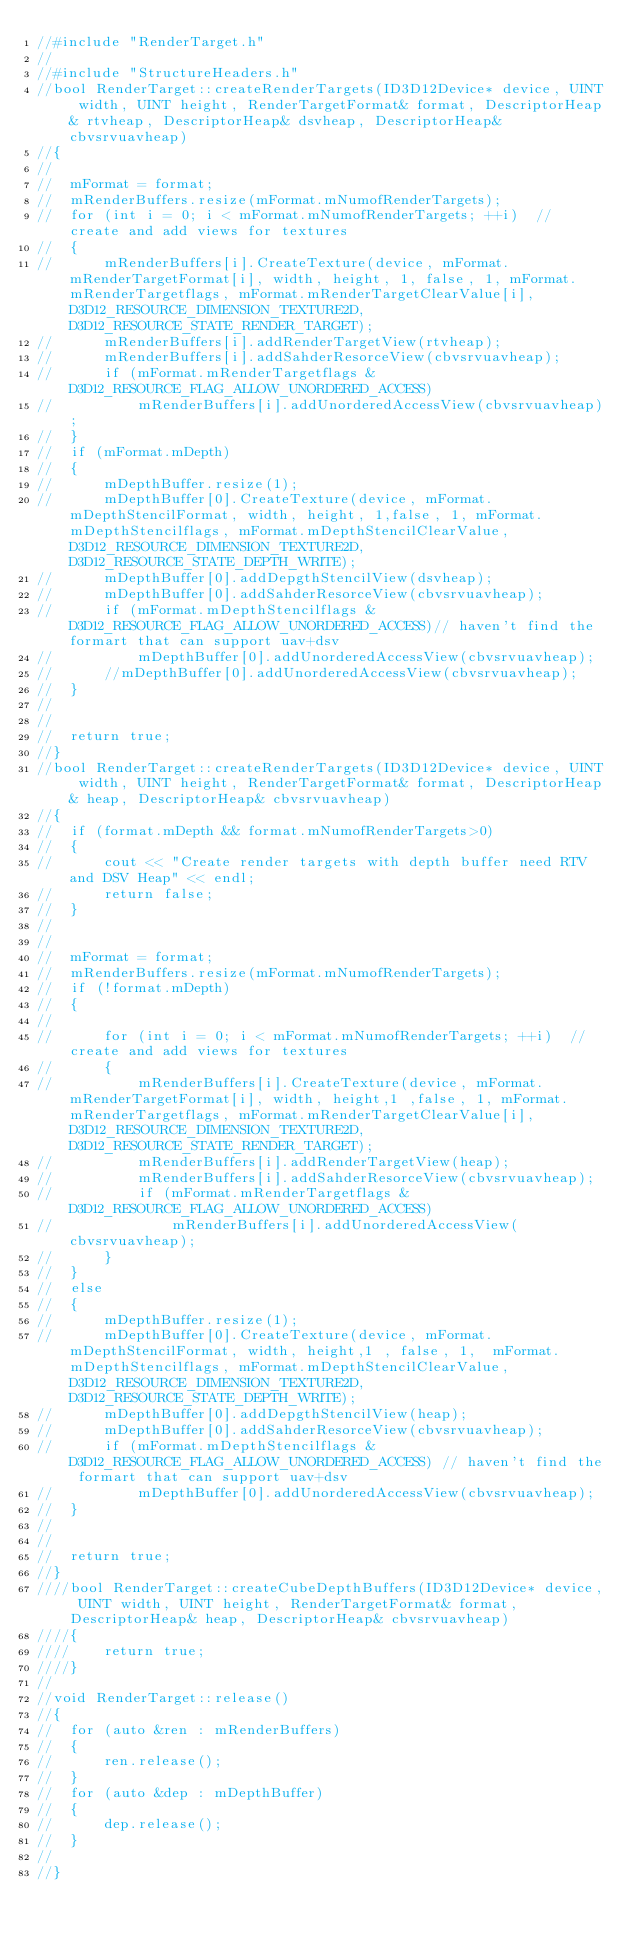Convert code to text. <code><loc_0><loc_0><loc_500><loc_500><_C++_>//#include "RenderTarget.h"
//
//#include "StructureHeaders.h"
//bool RenderTarget::createRenderTargets(ID3D12Device* device, UINT width, UINT height, RenderTargetFormat& format, DescriptorHeap& rtvheap, DescriptorHeap& dsvheap, DescriptorHeap& cbvsrvuavheap)
//{
//
//	mFormat = format;
//	mRenderBuffers.resize(mFormat.mNumofRenderTargets);
//	for (int i = 0; i < mFormat.mNumofRenderTargets; ++i)  // create and add views for textures 
//	{
//		mRenderBuffers[i].CreateTexture(device, mFormat.mRenderTargetFormat[i], width, height, 1, false, 1, mFormat.mRenderTargetflags, mFormat.mRenderTargetClearValue[i], D3D12_RESOURCE_DIMENSION_TEXTURE2D, D3D12_RESOURCE_STATE_RENDER_TARGET);
//		mRenderBuffers[i].addRenderTargetView(rtvheap);
//		mRenderBuffers[i].addSahderResorceView(cbvsrvuavheap);
//		if (mFormat.mRenderTargetflags & D3D12_RESOURCE_FLAG_ALLOW_UNORDERED_ACCESS)
//			mRenderBuffers[i].addUnorderedAccessView(cbvsrvuavheap);
//	}
//	if (mFormat.mDepth)
//	{
//		mDepthBuffer.resize(1);
//		mDepthBuffer[0].CreateTexture(device, mFormat.mDepthStencilFormat, width, height, 1,false, 1, mFormat.mDepthStencilflags, mFormat.mDepthStencilClearValue,  D3D12_RESOURCE_DIMENSION_TEXTURE2D, D3D12_RESOURCE_STATE_DEPTH_WRITE);
//		mDepthBuffer[0].addDepgthStencilView(dsvheap);
//		mDepthBuffer[0].addSahderResorceView(cbvsrvuavheap);
//		if (mFormat.mDepthStencilflags & D3D12_RESOURCE_FLAG_ALLOW_UNORDERED_ACCESS)// haven't find the formart that can support uav+dsv
//			mDepthBuffer[0].addUnorderedAccessView(cbvsrvuavheap);
//		//mDepthBuffer[0].addUnorderedAccessView(cbvsrvuavheap);
//	}
//
//
//	return true;
//}
//bool RenderTarget::createRenderTargets(ID3D12Device* device, UINT width, UINT height, RenderTargetFormat& format, DescriptorHeap& heap, DescriptorHeap& cbvsrvuavheap)
//{
//	if (format.mDepth && format.mNumofRenderTargets>0)
//	{
//		cout << "Create render targets with depth buffer need RTV and DSV Heap" << endl;
//		return false;
//	}
//
//	
//	mFormat = format;
//	mRenderBuffers.resize(mFormat.mNumofRenderTargets);
//	if (!format.mDepth)
//	{
//		
//		for (int i = 0; i < mFormat.mNumofRenderTargets; ++i)  // create and add views for textures 
//		{
//			mRenderBuffers[i].CreateTexture(device, mFormat.mRenderTargetFormat[i], width, height,1 ,false, 1, mFormat.mRenderTargetflags, mFormat.mRenderTargetClearValue[i], D3D12_RESOURCE_DIMENSION_TEXTURE2D, D3D12_RESOURCE_STATE_RENDER_TARGET);
//			mRenderBuffers[i].addRenderTargetView(heap);
//			mRenderBuffers[i].addSahderResorceView(cbvsrvuavheap);
//			if (mFormat.mRenderTargetflags & D3D12_RESOURCE_FLAG_ALLOW_UNORDERED_ACCESS) 
//				mRenderBuffers[i].addUnorderedAccessView(cbvsrvuavheap);
//		}
//	}
//	else
//	{
//		mDepthBuffer.resize(1);
//		mDepthBuffer[0].CreateTexture(device, mFormat.mDepthStencilFormat, width, height,1 , false, 1,  mFormat.mDepthStencilflags, mFormat.mDepthStencilClearValue, D3D12_RESOURCE_DIMENSION_TEXTURE2D, D3D12_RESOURCE_STATE_DEPTH_WRITE);
//		mDepthBuffer[0].addDepgthStencilView(heap);
//		mDepthBuffer[0].addSahderResorceView(cbvsrvuavheap);
//		if (mFormat.mDepthStencilflags & D3D12_RESOURCE_FLAG_ALLOW_UNORDERED_ACCESS) // haven't find the formart that can support uav+dsv
//			mDepthBuffer[0].addUnorderedAccessView(cbvsrvuavheap);
//	}
//
//
//	return true;
//}
////bool RenderTarget::createCubeDepthBuffers(ID3D12Device* device, UINT width, UINT height, RenderTargetFormat& format, DescriptorHeap& heap, DescriptorHeap& cbvsrvuavheap)
////{
////	return true;
////}
//
//void RenderTarget::release()
//{
//	for (auto &ren : mRenderBuffers)
//	{
//		ren.release();
//	}
//	for (auto &dep : mDepthBuffer)
//	{
//		dep.release();
//	}
//
//}</code> 